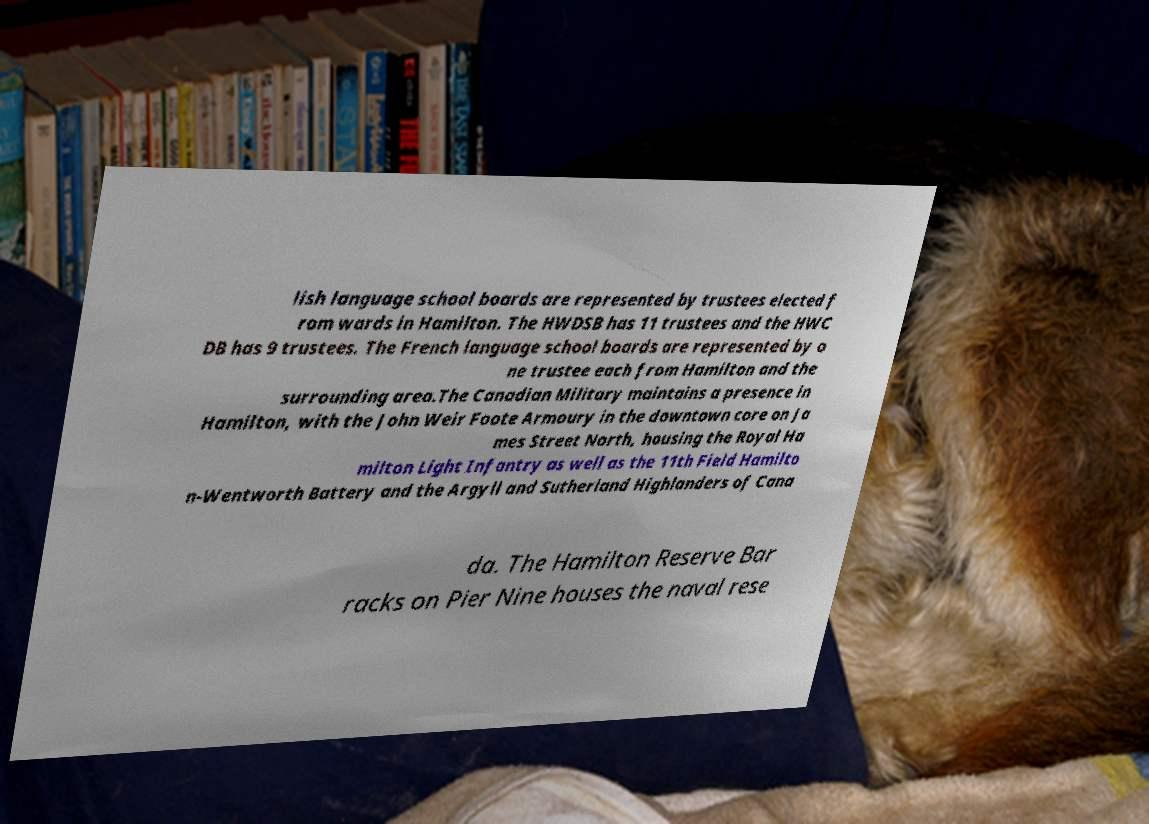What messages or text are displayed in this image? I need them in a readable, typed format. lish language school boards are represented by trustees elected f rom wards in Hamilton. The HWDSB has 11 trustees and the HWC DB has 9 trustees. The French language school boards are represented by o ne trustee each from Hamilton and the surrounding area.The Canadian Military maintains a presence in Hamilton, with the John Weir Foote Armoury in the downtown core on Ja mes Street North, housing the Royal Ha milton Light Infantry as well as the 11th Field Hamilto n-Wentworth Battery and the Argyll and Sutherland Highlanders of Cana da. The Hamilton Reserve Bar racks on Pier Nine houses the naval rese 